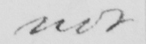What is written in this line of handwriting? not 